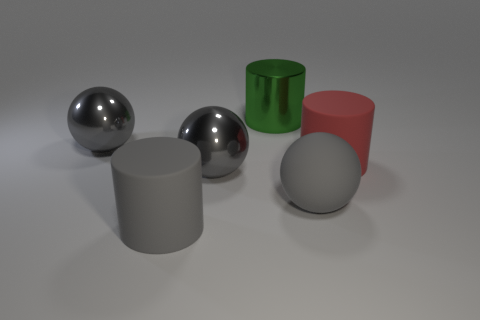What color is the other cylinder that is made of the same material as the big red cylinder?
Offer a very short reply. Gray. Is the number of gray shiny spheres greater than the number of big red matte cylinders?
Provide a short and direct response. Yes. How many objects are either cylinders that are to the right of the green thing or big red cylinders?
Offer a terse response. 1. Are there any purple metallic cubes that have the same size as the rubber ball?
Make the answer very short. No. Is the number of small green metallic blocks less than the number of large metal objects?
Provide a succinct answer. Yes. What number of blocks are either red objects or large things?
Keep it short and to the point. 0. What number of metal spheres have the same color as the metallic cylinder?
Give a very brief answer. 0. How big is the cylinder that is left of the big red matte thing and in front of the green thing?
Your response must be concise. Large. Are there fewer shiny objects that are on the left side of the big red thing than shiny spheres?
Your response must be concise. No. Do the green cylinder and the big red cylinder have the same material?
Offer a very short reply. No. 